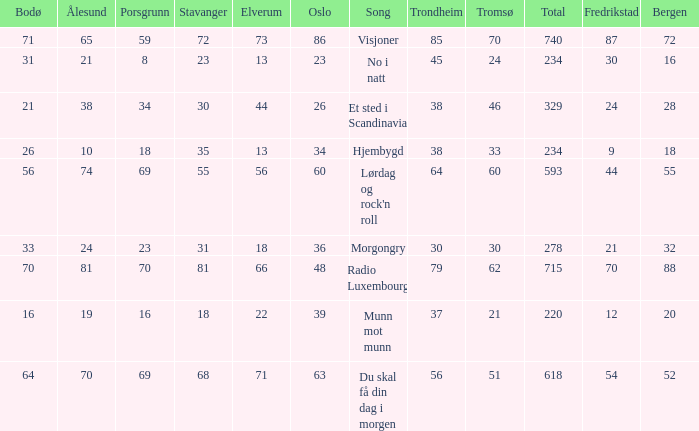When oslo is 48, what is stavanger? 81.0. 